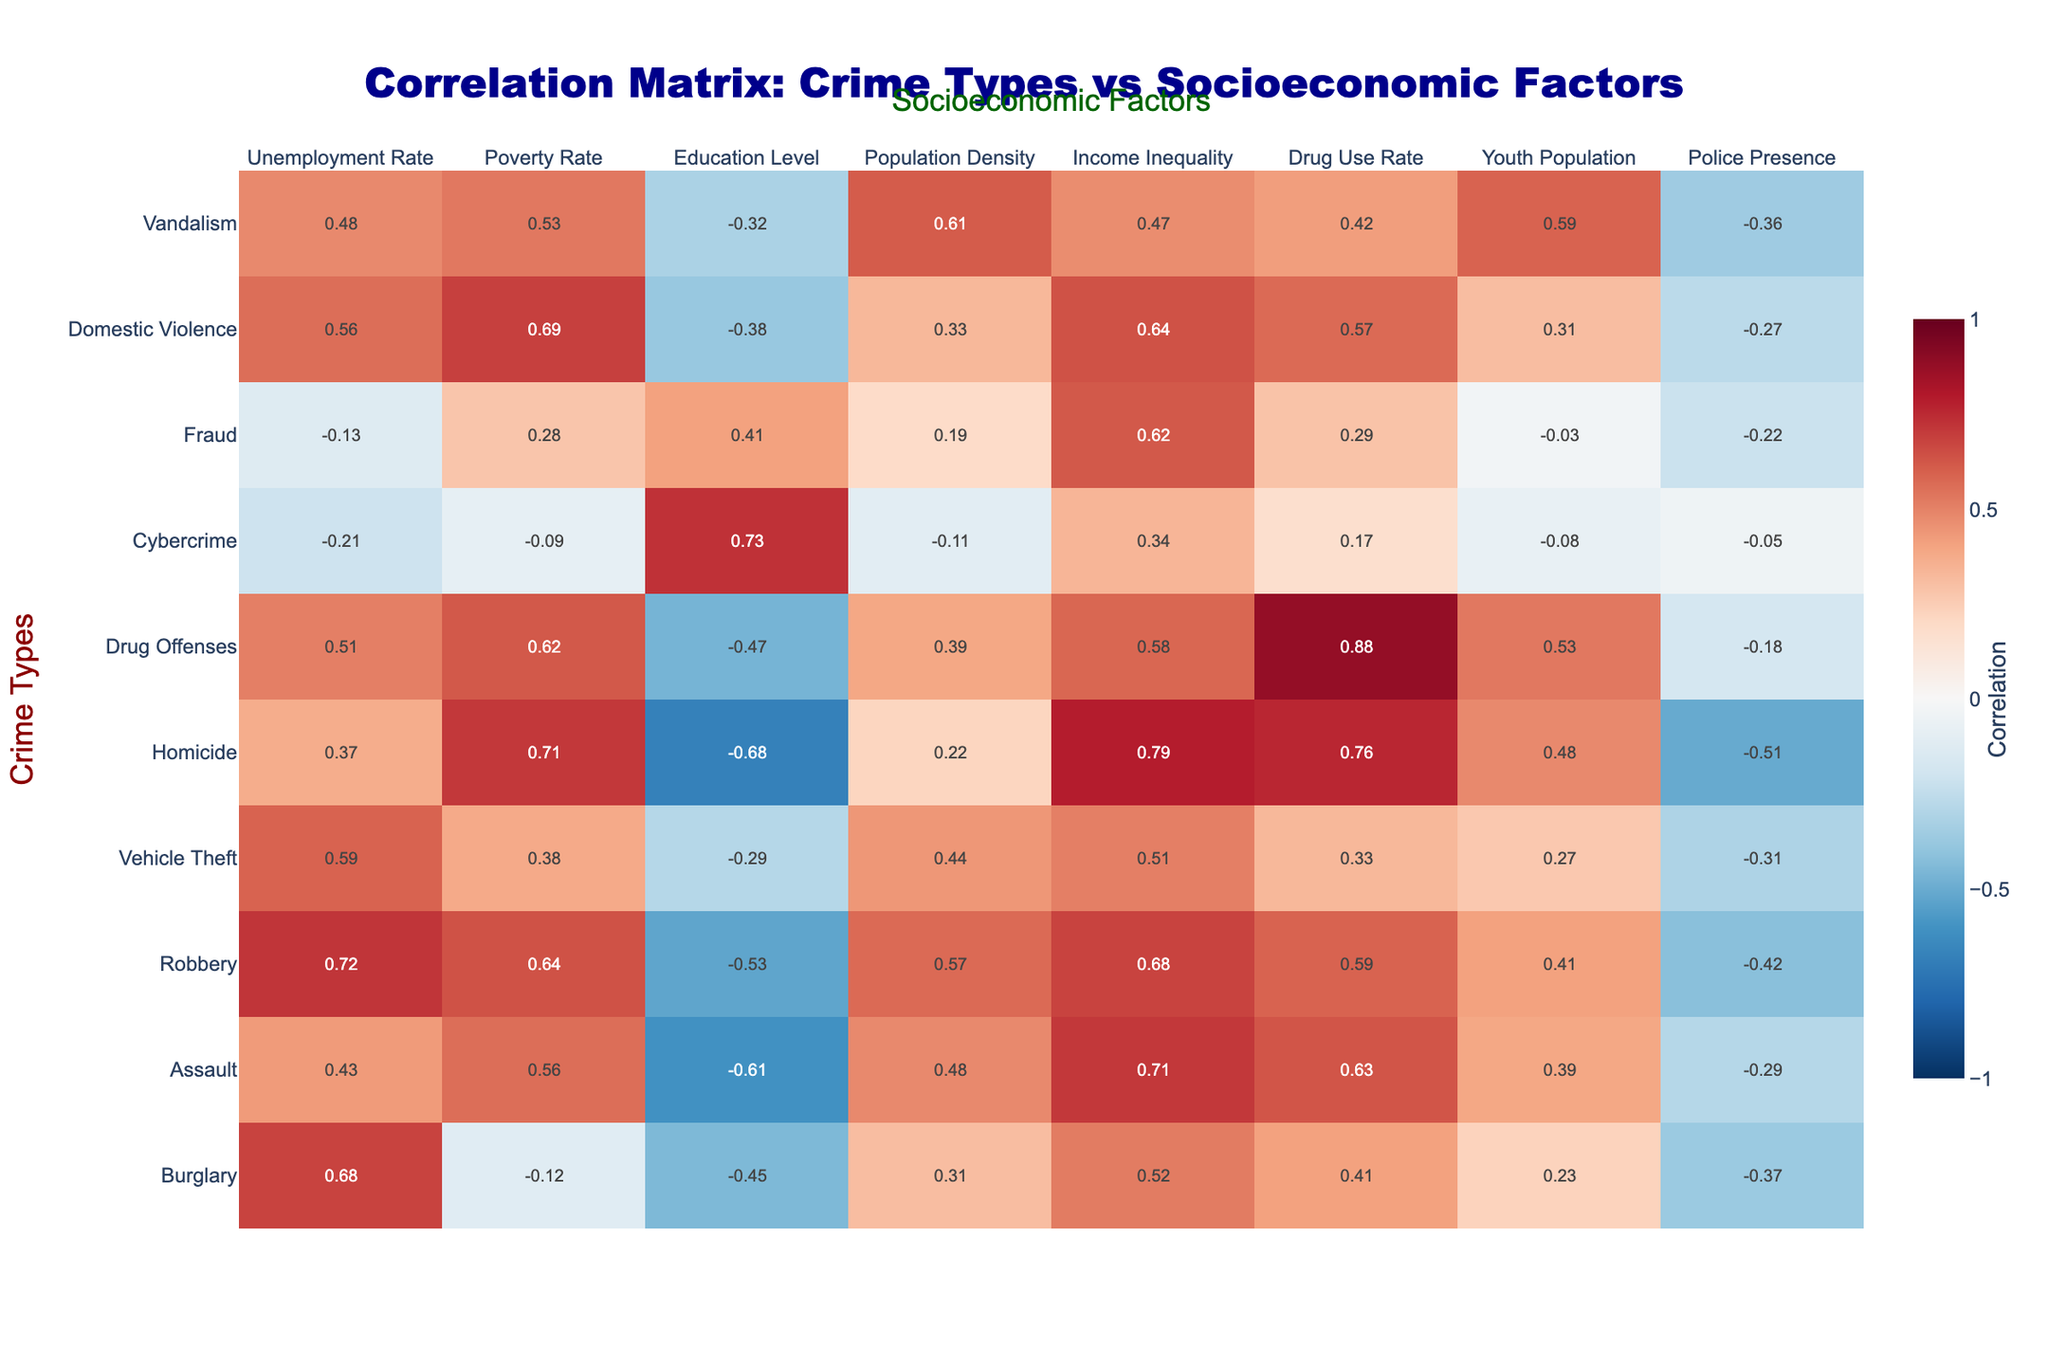What is the correlation between burglary and the unemployment rate? The table shows that the correlation between burglary and the unemployment rate is 0.68. This indicates a strong positive correlation.
Answer: 0.68 What is the correlation value for drug offenses and drug use rate? The table indicates that the correlation value for drug offenses and drug use rate is 0.88, which is the highest correlation in the table.
Answer: 0.88 Which crime type has the highest correlation with poverty rate? Referring to the table, the crime type with the highest correlation with the poverty rate is homicide, with a value of 0.71.
Answer: Homicide What is the average correlation of the crime types with income inequality? To find the average correlation, sum the values for each crime type with income inequality and divide by the number of observations: (0.52 + 0.71 + 0.68 + 0.51 + 0.79 + 0.58 + 0.34 + 0.62 + 0.64 + 0.47) = 6.43, then 6.43/10 = 0.643
Answer: 0.643 Is there a negative correlation between any crime types and police presence? Yes, the data shows negative correlations for all crime types with police presence, with values ranging from -0.05 to -0.51.
Answer: Yes Which socioeconomic factor has the highest overall correlation with crime types? The socioeconomic factor with the highest overall correlation with crime types is drug use rate, with an average correlation of 0.563.
Answer: Drug use rate How does the correlation of vehicle theft with population density compare to that of robbery? Vehicle theft has a correlation of 0.44 with population density, while robbery has a higher correlation of 0.57. Therefore, robbery has a stronger positive correlation with population density.
Answer: Robbery has a stronger correlation What can we infer about the relationship between education level and assault? The table shows a correlation of -0.61 between education level and assault, suggesting that higher education levels are associated with lower rates of assault.
Answer: Higher education is associated with lower assault rates Which two crime types are most negatively correlated with drug use rate? Looking at the table, cybercrime and fraud both have relatively low positive correlations with drug use rate at 0.17 and 0.29, thus relatively they have the least positive association.
Answer: Cybercrime and fraud Are there any crime types that do not correlate positively with either poverty rate or unemployment rate? Yes, cybercrime shows a minimal negative correlation with both poverty rate and unemployment rate (-0.09 and -0.21 respectively).
Answer: Yes, cybercrime does not correlate positively 